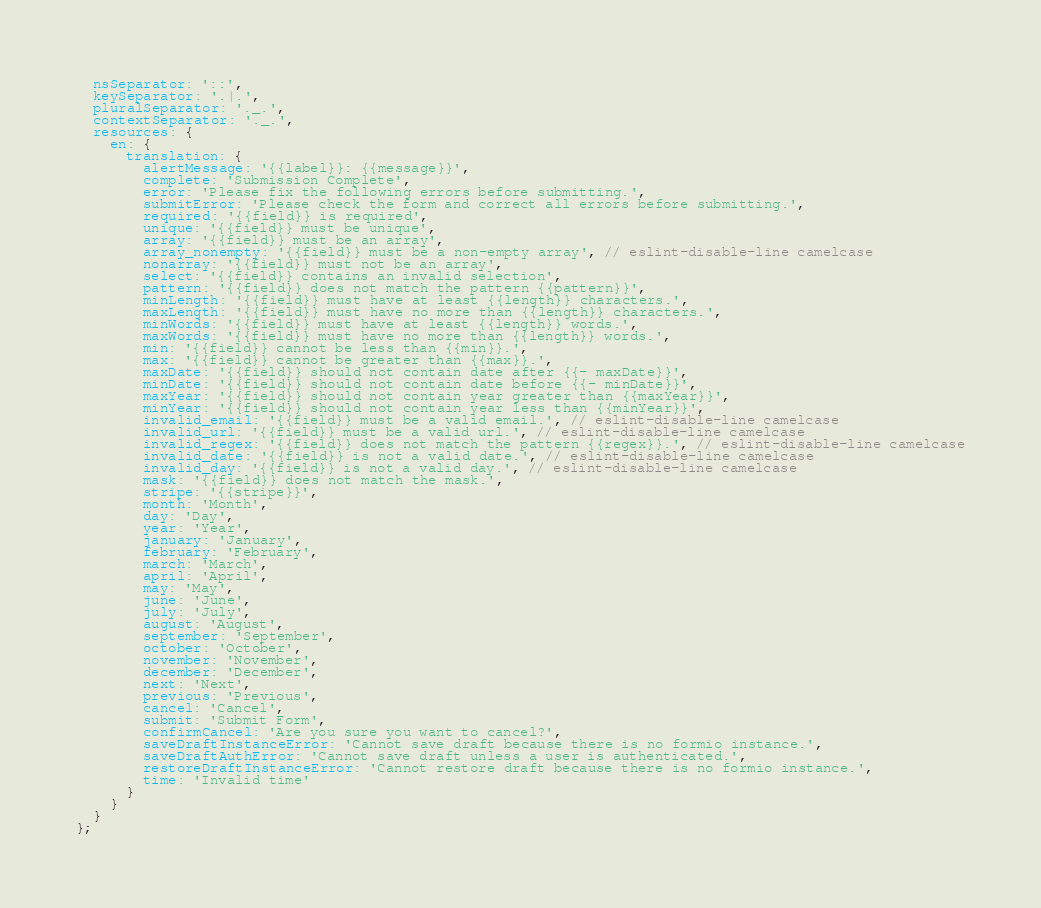<code> <loc_0><loc_0><loc_500><loc_500><_JavaScript_>  nsSeparator: '::',
  keySeparator: '.|.',
  pluralSeparator: '._.',
  contextSeparator: '._.',
  resources: {
    en: {
      translation: {
        alertMessage: '{{label}}: {{message}}',
        complete: 'Submission Complete',
        error: 'Please fix the following errors before submitting.',
        submitError: 'Please check the form and correct all errors before submitting.',
        required: '{{field}} is required',
        unique: '{{field}} must be unique',
        array: '{{field}} must be an array',
        array_nonempty: '{{field}} must be a non-empty array', // eslint-disable-line camelcase
        nonarray: '{{field}} must not be an array',
        select: '{{field}} contains an invalid selection',
        pattern: '{{field}} does not match the pattern {{pattern}}',
        minLength: '{{field}} must have at least {{length}} characters.',
        maxLength: '{{field}} must have no more than {{length}} characters.',
        minWords: '{{field}} must have at least {{length}} words.',
        maxWords: '{{field}} must have no more than {{length}} words.',
        min: '{{field}} cannot be less than {{min}}.',
        max: '{{field}} cannot be greater than {{max}}.',
        maxDate: '{{field}} should not contain date after {{- maxDate}}',
        minDate: '{{field}} should not contain date before {{- minDate}}',
        maxYear: '{{field}} should not contain year greater than {{maxYear}}',
        minYear: '{{field}} should not contain year less than {{minYear}}',
        invalid_email: '{{field}} must be a valid email.', // eslint-disable-line camelcase
        invalid_url: '{{field}} must be a valid url.', // eslint-disable-line camelcase
        invalid_regex: '{{field}} does not match the pattern {{regex}}.', // eslint-disable-line camelcase
        invalid_date: '{{field}} is not a valid date.', // eslint-disable-line camelcase
        invalid_day: '{{field}} is not a valid day.', // eslint-disable-line camelcase
        mask: '{{field}} does not match the mask.',
        stripe: '{{stripe}}',
        month: 'Month',
        day: 'Day',
        year: 'Year',
        january: 'January',
        february: 'February',
        march: 'March',
        april: 'April',
        may: 'May',
        june: 'June',
        july: 'July',
        august: 'August',
        september: 'September',
        october: 'October',
        november: 'November',
        december: 'December',
        next: 'Next',
        previous: 'Previous',
        cancel: 'Cancel',
        submit: 'Submit Form',
        confirmCancel: 'Are you sure you want to cancel?',
        saveDraftInstanceError: 'Cannot save draft because there is no formio instance.',
        saveDraftAuthError: 'Cannot save draft unless a user is authenticated.',
        restoreDraftInstanceError: 'Cannot restore draft because there is no formio instance.',
        time: 'Invalid time'
      }
    }
  }
};
</code> 